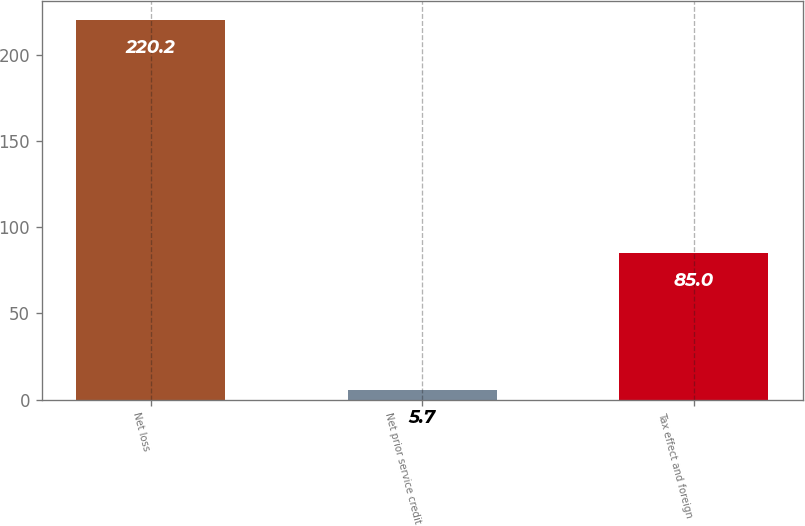<chart> <loc_0><loc_0><loc_500><loc_500><bar_chart><fcel>Net loss<fcel>Net prior service credit<fcel>Tax effect and foreign<nl><fcel>220.2<fcel>5.7<fcel>85<nl></chart> 